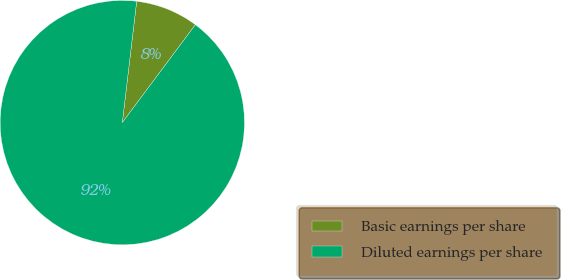Convert chart to OTSL. <chart><loc_0><loc_0><loc_500><loc_500><pie_chart><fcel>Basic earnings per share<fcel>Diluted earnings per share<nl><fcel>8.33%<fcel>91.67%<nl></chart> 